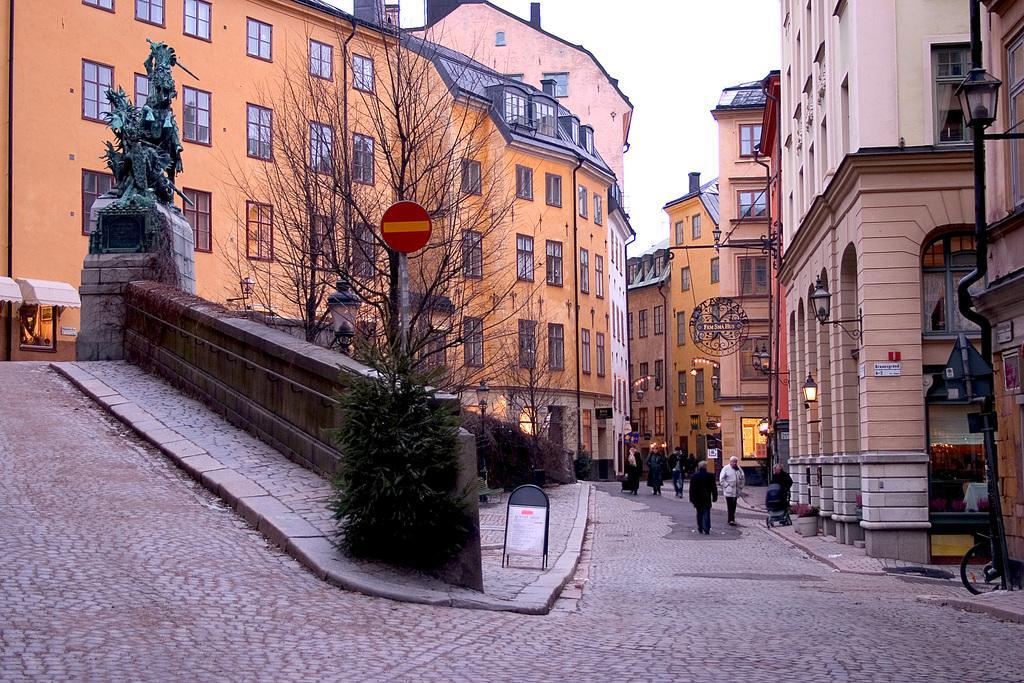Can you describe this image briefly? This is a picture clicked in a street. In the foreground of the picture there are plants, trees, street lights, sculpture and pavement. In the center of the background there are people walking down the road. In the background there are buildings, street lights and windows. Sky is cloudy. 